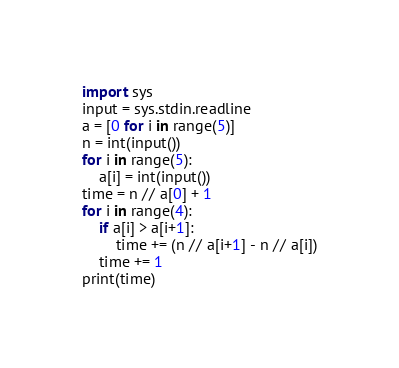<code> <loc_0><loc_0><loc_500><loc_500><_Python_>import sys
input = sys.stdin.readline
a = [0 for i in range(5)]
n = int(input())
for i in range(5):
    a[i] = int(input())
time = n // a[0] + 1
for i in range(4):
    if a[i] > a[i+1]:
        time += (n // a[i+1] - n // a[i])
    time += 1
print(time)</code> 